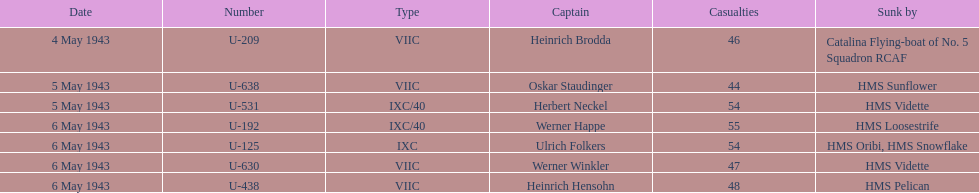Which ship was responsible for sinking the most submarines? HMS Vidette. 